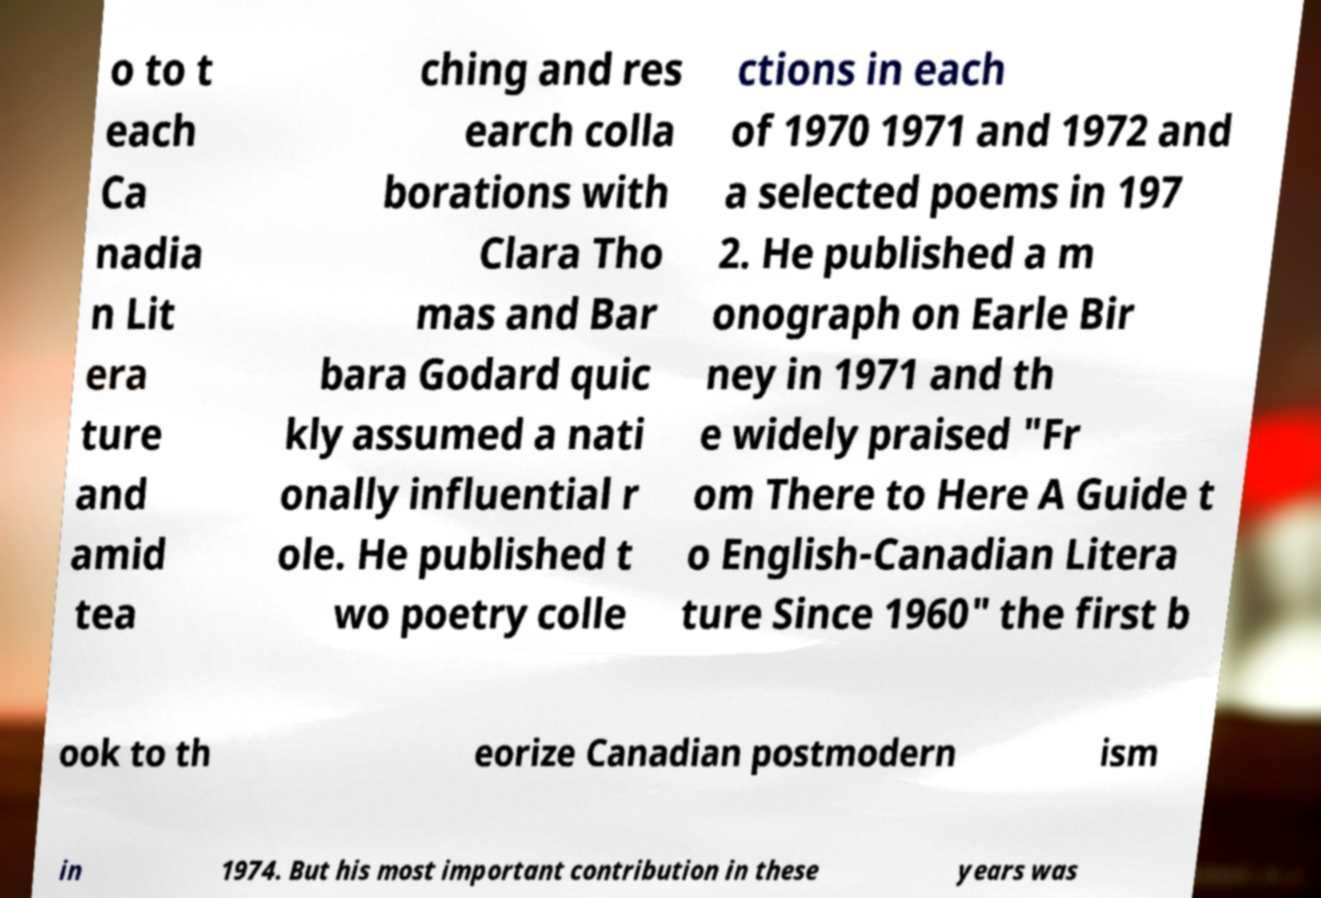Could you extract and type out the text from this image? o to t each Ca nadia n Lit era ture and amid tea ching and res earch colla borations with Clara Tho mas and Bar bara Godard quic kly assumed a nati onally influential r ole. He published t wo poetry colle ctions in each of 1970 1971 and 1972 and a selected poems in 197 2. He published a m onograph on Earle Bir ney in 1971 and th e widely praised "Fr om There to Here A Guide t o English-Canadian Litera ture Since 1960" the first b ook to th eorize Canadian postmodern ism in 1974. But his most important contribution in these years was 